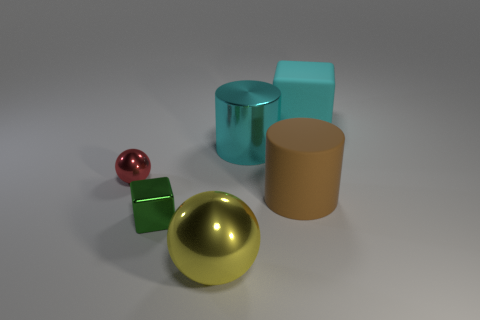Are there any other yellow shiny things that have the same shape as the yellow metallic object?
Offer a terse response. No. There is a sphere that is on the left side of the big yellow object; is it the same size as the metal ball that is on the right side of the metal cube?
Provide a short and direct response. No. Are there more small cyan metal spheres than blocks?
Give a very brief answer. No. How many yellow spheres have the same material as the cyan block?
Provide a succinct answer. 0. Is the shape of the red metallic object the same as the cyan matte object?
Provide a succinct answer. No. There is a metallic thing that is to the left of the small metallic object right of the sphere that is behind the matte cylinder; what size is it?
Keep it short and to the point. Small. There is a big shiny object that is in front of the large metal cylinder; are there any large cyan rubber things that are in front of it?
Your answer should be compact. No. There is a big cylinder in front of the small thing that is on the left side of the small green cube; how many cyan metallic cylinders are in front of it?
Provide a short and direct response. 0. The large object that is both behind the large brown thing and to the left of the cyan rubber cube is what color?
Provide a short and direct response. Cyan. What number of rubber cubes are the same color as the large shiny cylinder?
Your response must be concise. 1. 